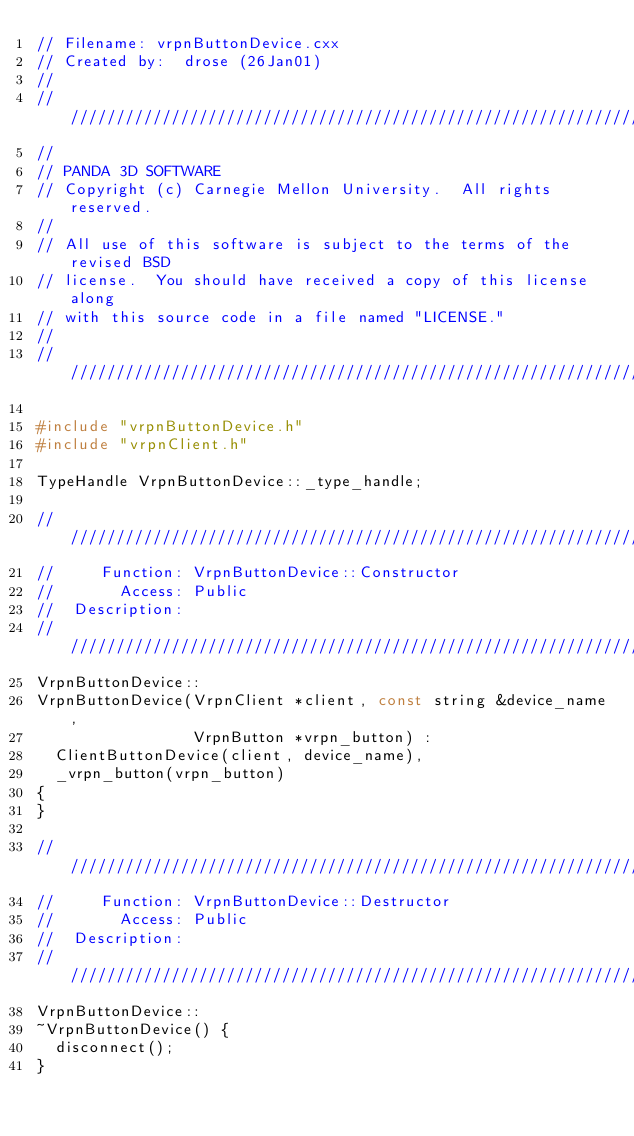Convert code to text. <code><loc_0><loc_0><loc_500><loc_500><_C++_>// Filename: vrpnButtonDevice.cxx
// Created by:  drose (26Jan01)
//
////////////////////////////////////////////////////////////////////
//
// PANDA 3D SOFTWARE
// Copyright (c) Carnegie Mellon University.  All rights reserved.
//
// All use of this software is subject to the terms of the revised BSD
// license.  You should have received a copy of this license along
// with this source code in a file named "LICENSE."
//
////////////////////////////////////////////////////////////////////

#include "vrpnButtonDevice.h"
#include "vrpnClient.h"

TypeHandle VrpnButtonDevice::_type_handle;

////////////////////////////////////////////////////////////////////
//     Function: VrpnButtonDevice::Constructor
//       Access: Public
//  Description:
////////////////////////////////////////////////////////////////////
VrpnButtonDevice::
VrpnButtonDevice(VrpnClient *client, const string &device_name,
                 VrpnButton *vrpn_button) :
  ClientButtonDevice(client, device_name),
  _vrpn_button(vrpn_button)
{
}

////////////////////////////////////////////////////////////////////
//     Function: VrpnButtonDevice::Destructor
//       Access: Public
//  Description:
////////////////////////////////////////////////////////////////////
VrpnButtonDevice::
~VrpnButtonDevice() {
  disconnect();
}
</code> 